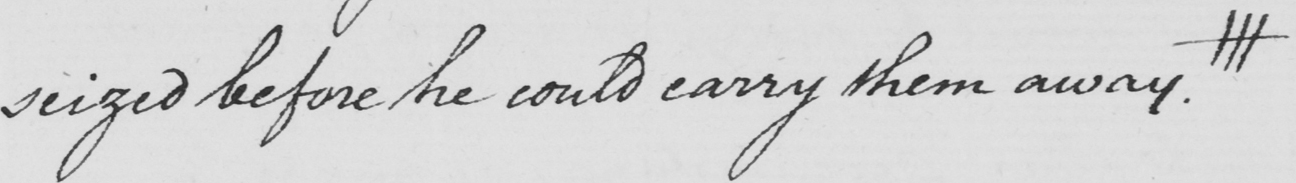What is written in this line of handwriting? seized before he could carry them away . ||| 